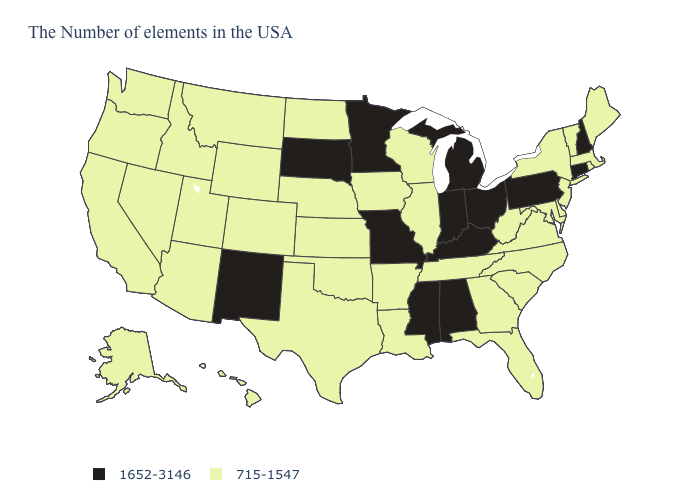Does Delaware have the highest value in the USA?
Keep it brief. No. Which states have the lowest value in the MidWest?
Be succinct. Wisconsin, Illinois, Iowa, Kansas, Nebraska, North Dakota. What is the highest value in the USA?
Give a very brief answer. 1652-3146. Among the states that border West Virginia , does Kentucky have the lowest value?
Keep it brief. No. What is the value of Alaska?
Be succinct. 715-1547. Name the states that have a value in the range 1652-3146?
Give a very brief answer. New Hampshire, Connecticut, Pennsylvania, Ohio, Michigan, Kentucky, Indiana, Alabama, Mississippi, Missouri, Minnesota, South Dakota, New Mexico. What is the highest value in the West ?
Short answer required. 1652-3146. Name the states that have a value in the range 1652-3146?
Give a very brief answer. New Hampshire, Connecticut, Pennsylvania, Ohio, Michigan, Kentucky, Indiana, Alabama, Mississippi, Missouri, Minnesota, South Dakota, New Mexico. What is the lowest value in states that border New Mexico?
Concise answer only. 715-1547. Name the states that have a value in the range 1652-3146?
Concise answer only. New Hampshire, Connecticut, Pennsylvania, Ohio, Michigan, Kentucky, Indiana, Alabama, Mississippi, Missouri, Minnesota, South Dakota, New Mexico. Name the states that have a value in the range 715-1547?
Concise answer only. Maine, Massachusetts, Rhode Island, Vermont, New York, New Jersey, Delaware, Maryland, Virginia, North Carolina, South Carolina, West Virginia, Florida, Georgia, Tennessee, Wisconsin, Illinois, Louisiana, Arkansas, Iowa, Kansas, Nebraska, Oklahoma, Texas, North Dakota, Wyoming, Colorado, Utah, Montana, Arizona, Idaho, Nevada, California, Washington, Oregon, Alaska, Hawaii. Does the map have missing data?
Concise answer only. No. Is the legend a continuous bar?
Answer briefly. No. Does the first symbol in the legend represent the smallest category?
Write a very short answer. No. 